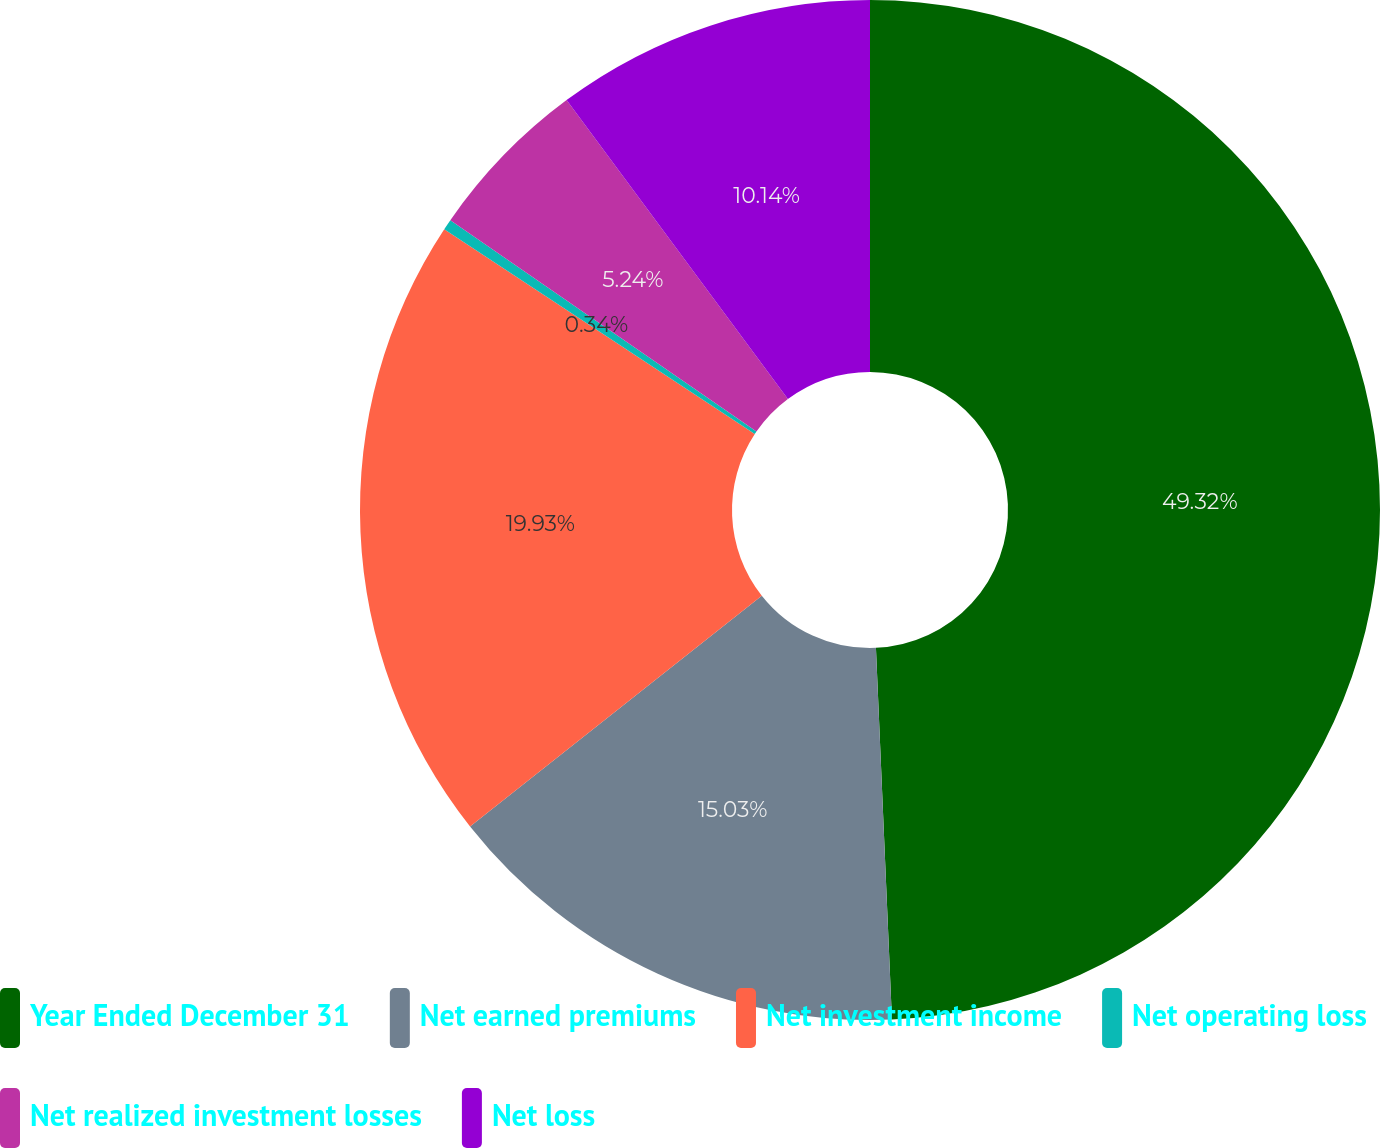Convert chart. <chart><loc_0><loc_0><loc_500><loc_500><pie_chart><fcel>Year Ended December 31<fcel>Net earned premiums<fcel>Net investment income<fcel>Net operating loss<fcel>Net realized investment losses<fcel>Net loss<nl><fcel>49.31%<fcel>15.03%<fcel>19.93%<fcel>0.34%<fcel>5.24%<fcel>10.14%<nl></chart> 